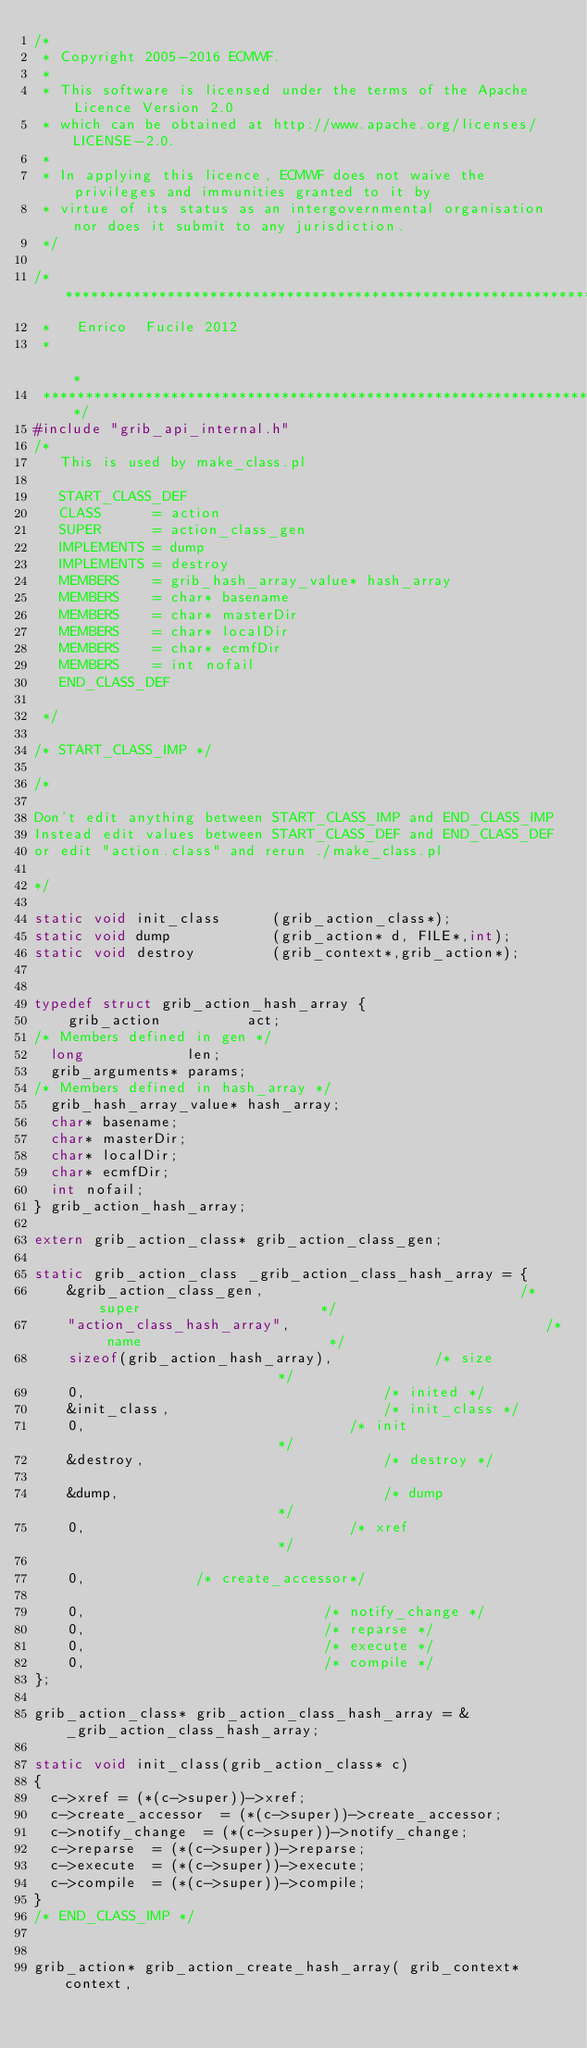Convert code to text. <code><loc_0><loc_0><loc_500><loc_500><_C_>/*
 * Copyright 2005-2016 ECMWF.
 *
 * This software is licensed under the terms of the Apache Licence Version 2.0
 * which can be obtained at http://www.apache.org/licenses/LICENSE-2.0.
 *
 * In applying this licence, ECMWF does not waive the privileges and immunities granted to it by
 * virtue of its status as an intergovernmental organisation nor does it submit to any jurisdiction.
 */

/***************************************************************************
 *   Enrico  Fucile 2012
 *                                                                         *
 ***************************************************************************/
#include "grib_api_internal.h"
/*
   This is used by make_class.pl

   START_CLASS_DEF
   CLASS      = action
   SUPER      = action_class_gen
   IMPLEMENTS = dump
   IMPLEMENTS = destroy
   MEMBERS    = grib_hash_array_value* hash_array
   MEMBERS    = char* basename
   MEMBERS    = char* masterDir
   MEMBERS    = char* localDir
   MEMBERS    = char* ecmfDir
   MEMBERS    = int nofail
   END_CLASS_DEF

 */

/* START_CLASS_IMP */

/*

Don't edit anything between START_CLASS_IMP and END_CLASS_IMP
Instead edit values between START_CLASS_DEF and END_CLASS_DEF
or edit "action.class" and rerun ./make_class.pl

*/

static void init_class      (grib_action_class*);
static void dump            (grib_action* d, FILE*,int);
static void destroy         (grib_context*,grib_action*);


typedef struct grib_action_hash_array {
    grib_action          act;  
/* Members defined in gen */
	long            len;
	grib_arguments* params;
/* Members defined in hash_array */
	grib_hash_array_value* hash_array;
	char* basename;
	char* masterDir;
	char* localDir;
	char* ecmfDir;
	int nofail;
} grib_action_hash_array;

extern grib_action_class* grib_action_class_gen;

static grib_action_class _grib_action_class_hash_array = {
    &grib_action_class_gen,                              /* super                     */
    "action_class_hash_array",                              /* name                      */
    sizeof(grib_action_hash_array),            /* size                      */
    0,                                   /* inited */
    &init_class,                         /* init_class */
    0,                               /* init                      */
    &destroy,                            /* destroy */

    &dump,                               /* dump                      */
    0,                               /* xref                      */

    0,             /* create_accessor*/

    0,                            /* notify_change */
    0,                            /* reparse */
    0,                            /* execute */
    0,                            /* compile */
};

grib_action_class* grib_action_class_hash_array = &_grib_action_class_hash_array;

static void init_class(grib_action_class* c)
{
	c->xref	=	(*(c->super))->xref;
	c->create_accessor	=	(*(c->super))->create_accessor;
	c->notify_change	=	(*(c->super))->notify_change;
	c->reparse	=	(*(c->super))->reparse;
	c->execute	=	(*(c->super))->execute;
	c->compile	=	(*(c->super))->compile;
}
/* END_CLASS_IMP */


grib_action* grib_action_create_hash_array( grib_context* context,</code> 